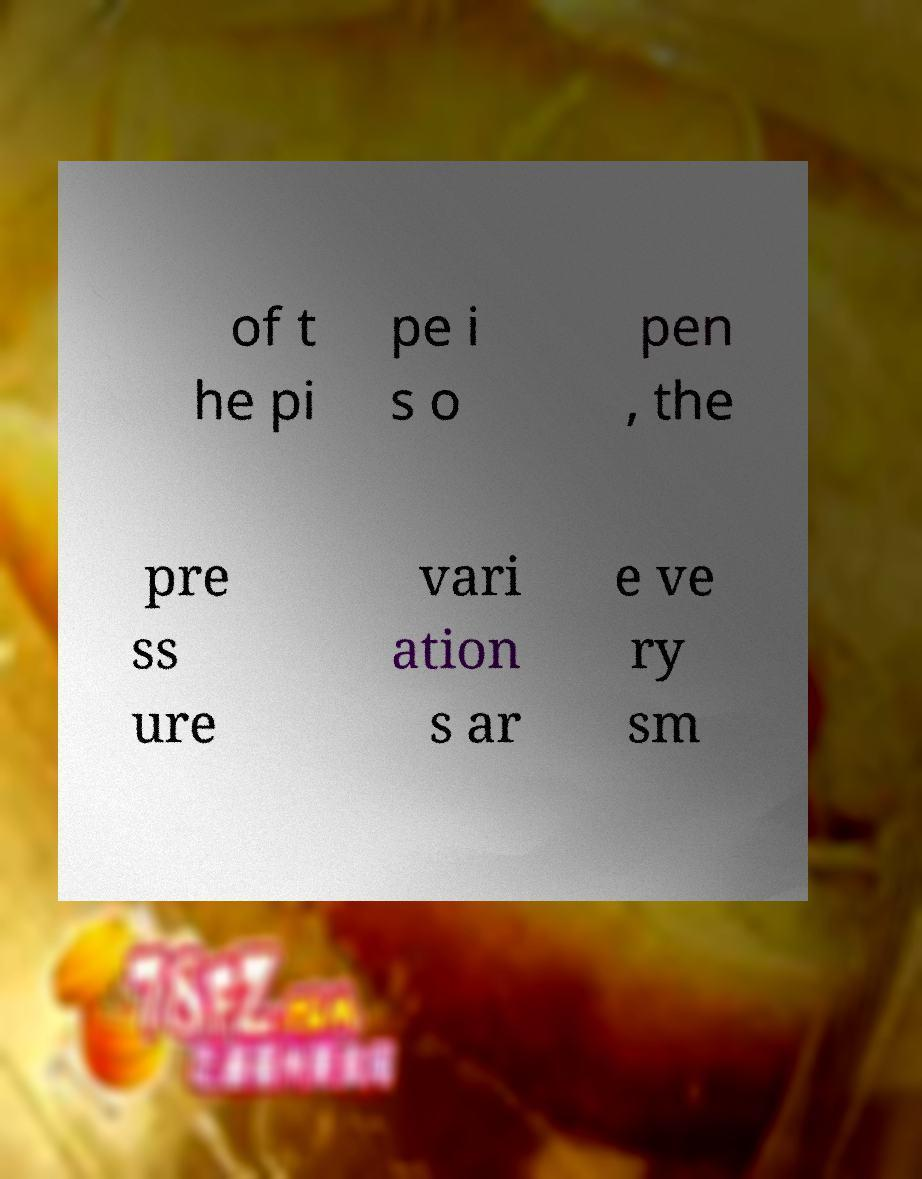Could you extract and type out the text from this image? of t he pi pe i s o pen , the pre ss ure vari ation s ar e ve ry sm 